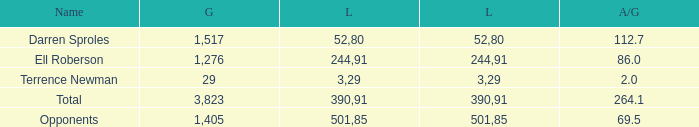When the Gain is 29, and the average per game is 2, and the player lost less than 390 yards, what's the sum of the Long yards? None. 